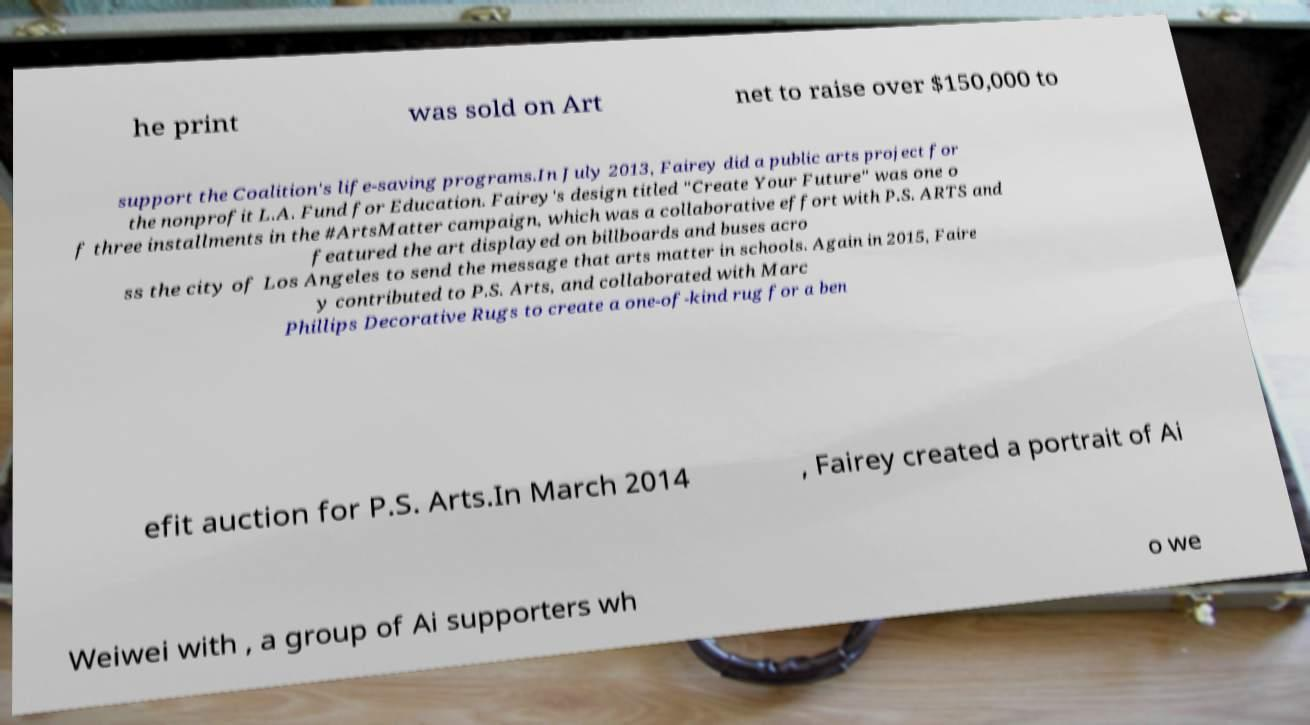Please read and relay the text visible in this image. What does it say? he print was sold on Art net to raise over $150,000 to support the Coalition's life-saving programs.In July 2013, Fairey did a public arts project for the nonprofit L.A. Fund for Education. Fairey's design titled "Create Your Future" was one o f three installments in the #ArtsMatter campaign, which was a collaborative effort with P.S. ARTS and featured the art displayed on billboards and buses acro ss the city of Los Angeles to send the message that arts matter in schools. Again in 2015, Faire y contributed to P.S. Arts, and collaborated with Marc Phillips Decorative Rugs to create a one-of-kind rug for a ben efit auction for P.S. Arts.In March 2014 , Fairey created a portrait of Ai Weiwei with , a group of Ai supporters wh o we 